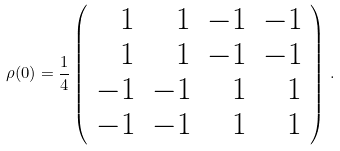Convert formula to latex. <formula><loc_0><loc_0><loc_500><loc_500>\rho ( 0 ) = \frac { 1 } { 4 } \left ( \begin{array} { r r r r } 1 & 1 & - 1 & - 1 \\ 1 & 1 & - 1 & - 1 \\ - 1 & - 1 & 1 & 1 \\ - 1 & - 1 & 1 & 1 \end{array} \right ) \, .</formula> 